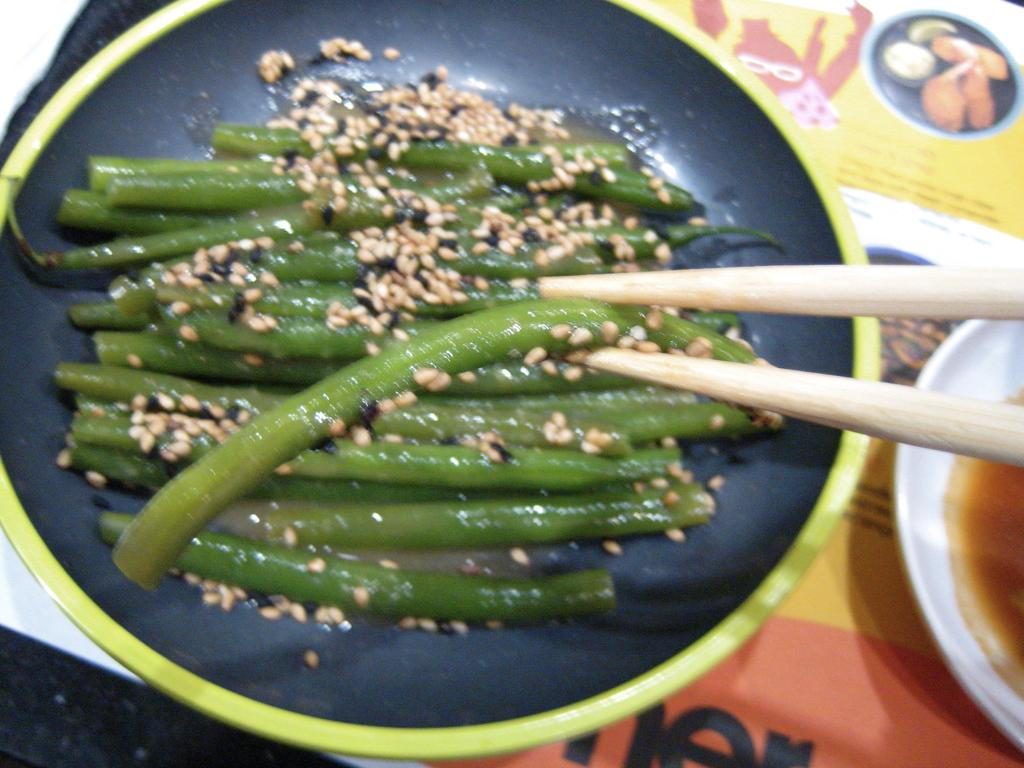What is being cooked or prepared in the pan in the image? The specific food items cannot be determined from the image, but there are food items in a pan. How are the food items being held or eaten in the image? A food item is held by chopsticks in the image. What accompanies the food items in the image? There is a bowl with sauce in the image. Where is the bowl with sauce located in the image? The bowl is on a table in the image. What type of clouds can be seen in the image? There are no clouds present in the image; it features food items in a pan, a food item held by chopsticks, a bowl with sauce, and a table. What type of soda is being served with the food in the image? There is no soda present in the image; it only features food items in a pan, a food item held by chopsticks, a bowl with sauce, and a table. 